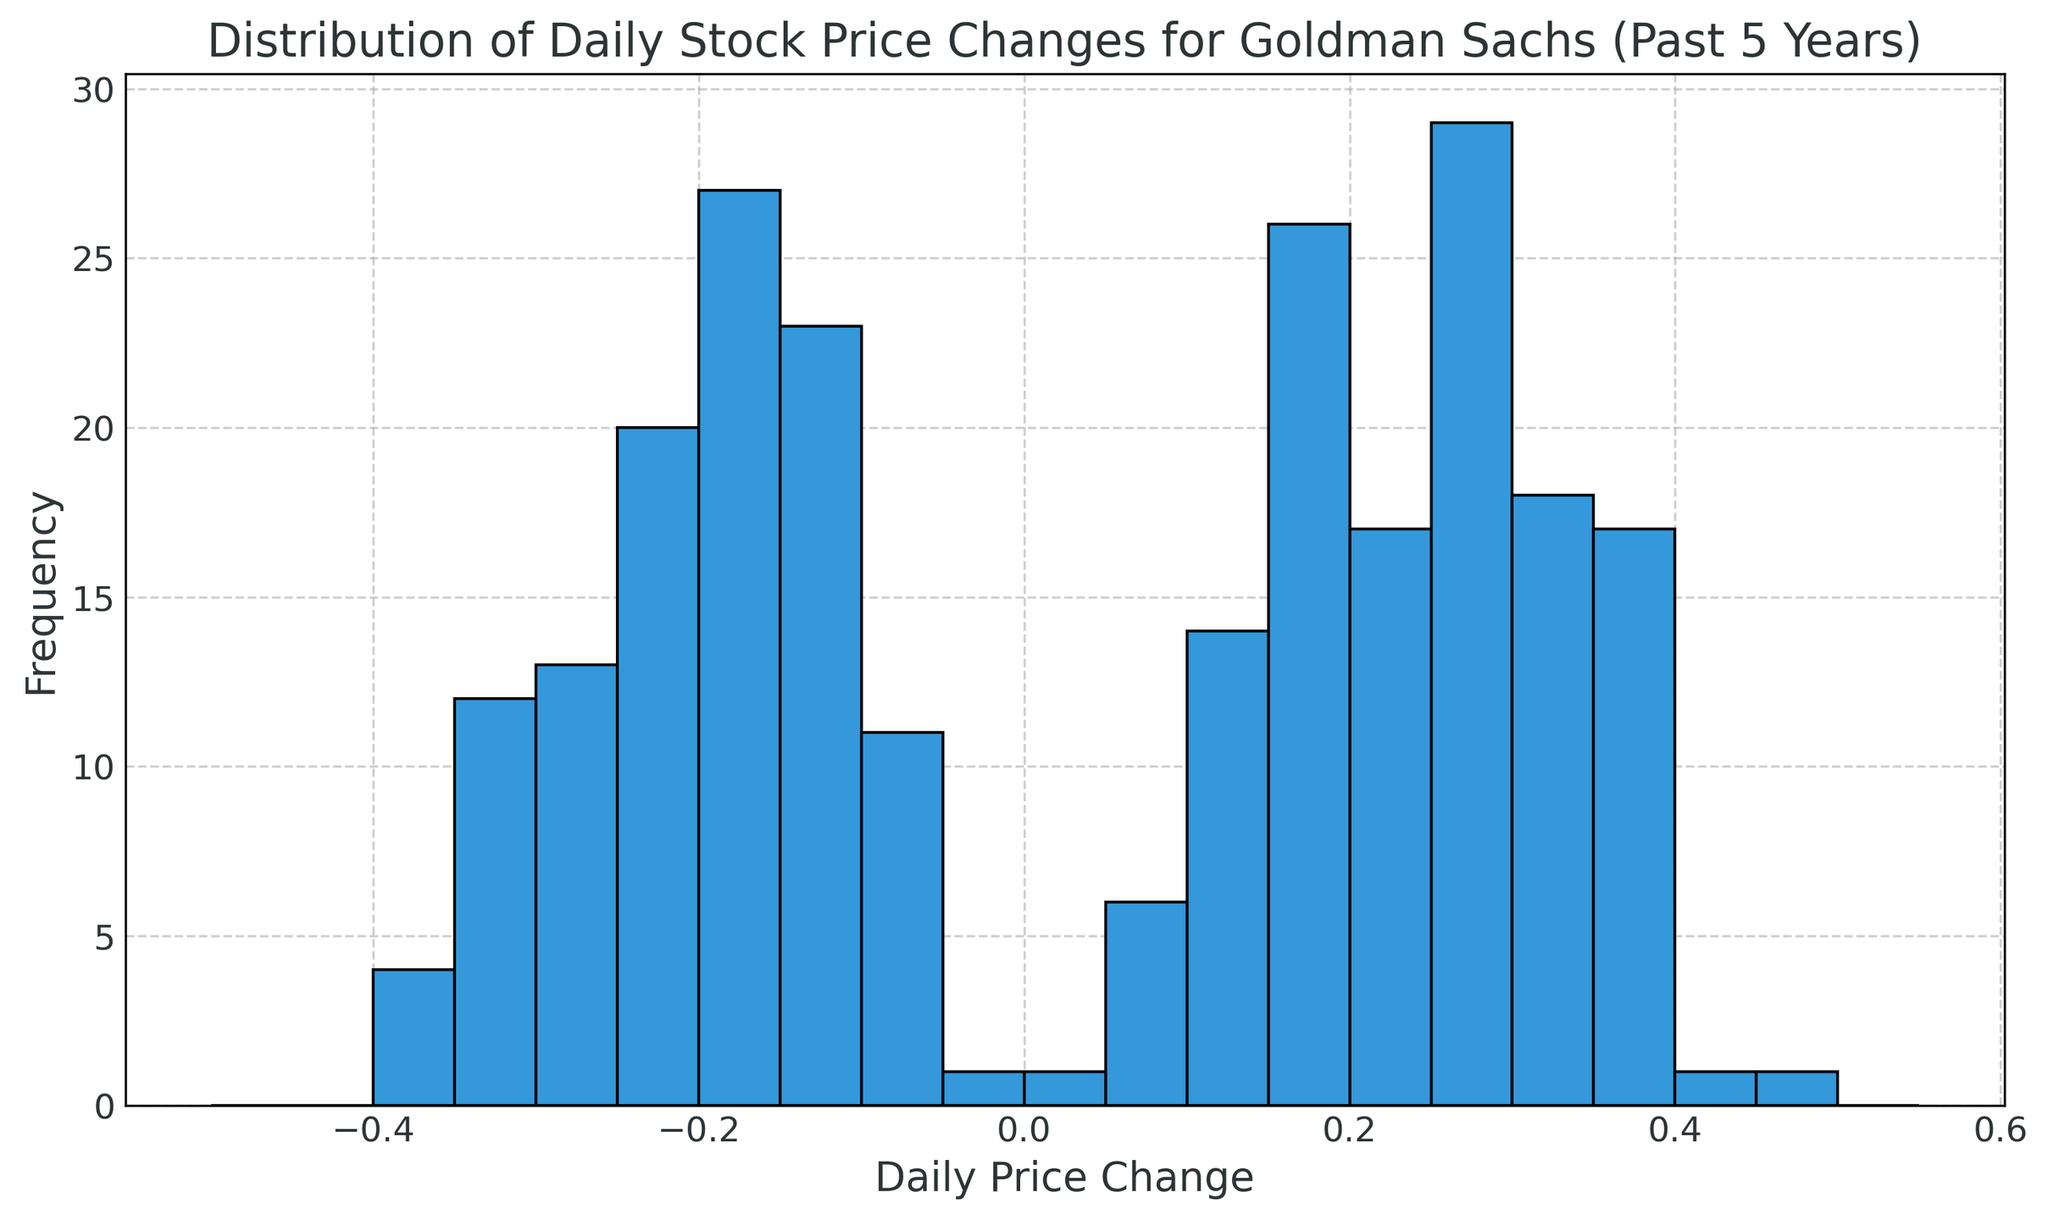Which daily price change interval is the most common? To determine the most common interval, I would look for the tallest bar in the histogram.
Answer: 0.30 to 0.35 How many days had a daily price change between -0.10 and -0.05? To answer this, I'd count the height of the bar within the -0.10 to -0.05 interval.
Answer: Approximately 5 days Is the number of days with a negative daily price change greater than those with a positive change? By comparing the sum of the bars on the negative side to those on the positive side, it can be determined.
Answer: Yes What is the range of daily price changes shown in the histogram? The range is determined by looking at the lowest and highest values on the x-axis.
Answer: -0.45 to 0.50 Which side of the histogram (positive or negative) has more variation in daily price changes? Variation can be assessed by looking at the spread and number of different intervals on each side of the x-axis.
Answer: Positive side How does the frequency of daily price changes between 0.20 to 0.25 compare to the frequency between -0.20 to -0.25? I'd compare the heights of the bars within these intervals on the histogram.
Answer: 0.20 to 0.25 is higher What is the second most common interval for daily price changes? The second tallest bar on the histogram indicates the second most common interval.
Answer: -0.25 to -0.20 Are there more days with minor price changes (between -0.05 to 0.05) compared to major price changes (above 0.30 or below -0.30)? I'd sum the heights of the bars between -0.05 to 0.05 and compare with those above 0.30 or below -0.30.
Answer: Yes Which interval has the least frequency of daily price changes? The shortest bar on the histogram indicates the least frequent interval.
Answer: -0.45 to -0.40 What is the frequency difference between the most common positive interval and the most common negative interval? I'd find the heights of these most common intervals and calculate the difference.
Answer: Approximately 5 days 